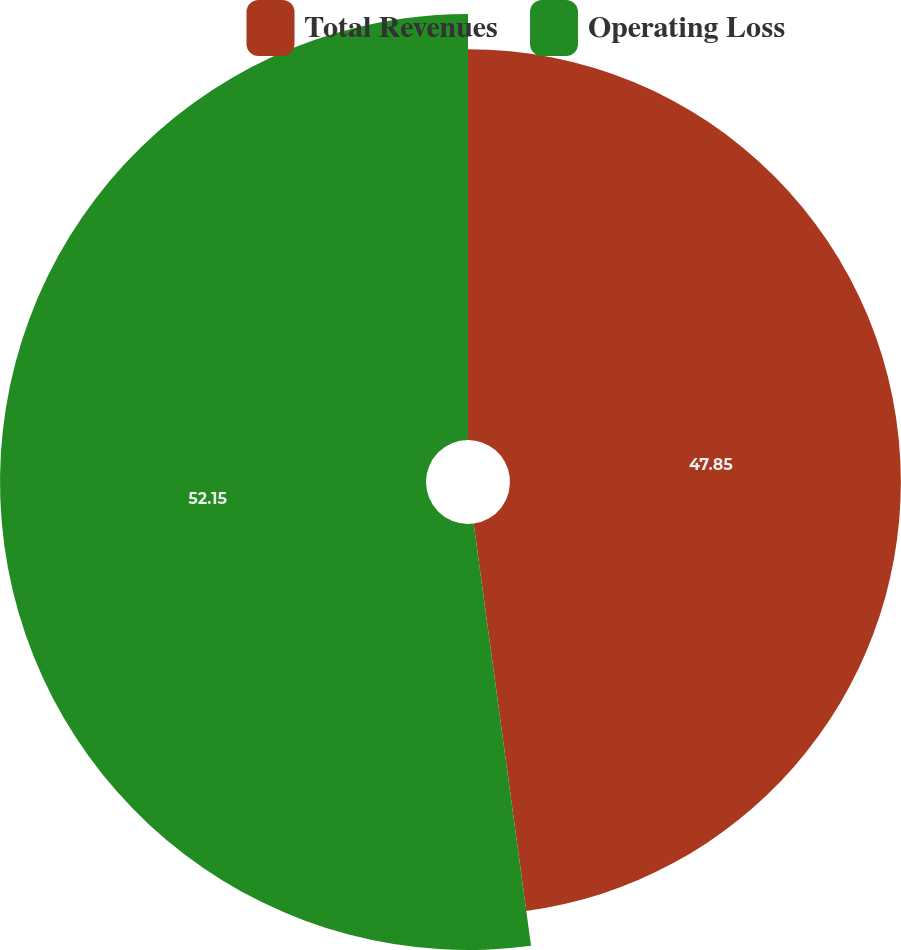<chart> <loc_0><loc_0><loc_500><loc_500><pie_chart><fcel>Total Revenues<fcel>Operating Loss<nl><fcel>47.85%<fcel>52.15%<nl></chart> 